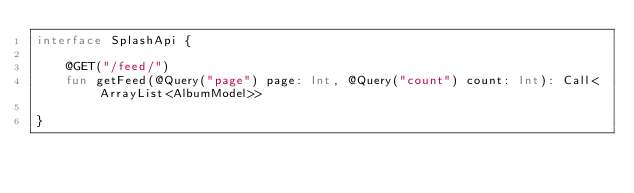Convert code to text. <code><loc_0><loc_0><loc_500><loc_500><_Kotlin_>interface SplashApi {

    @GET("/feed/")
    fun getFeed(@Query("page") page: Int, @Query("count") count: Int): Call<ArrayList<AlbumModel>>

}</code> 